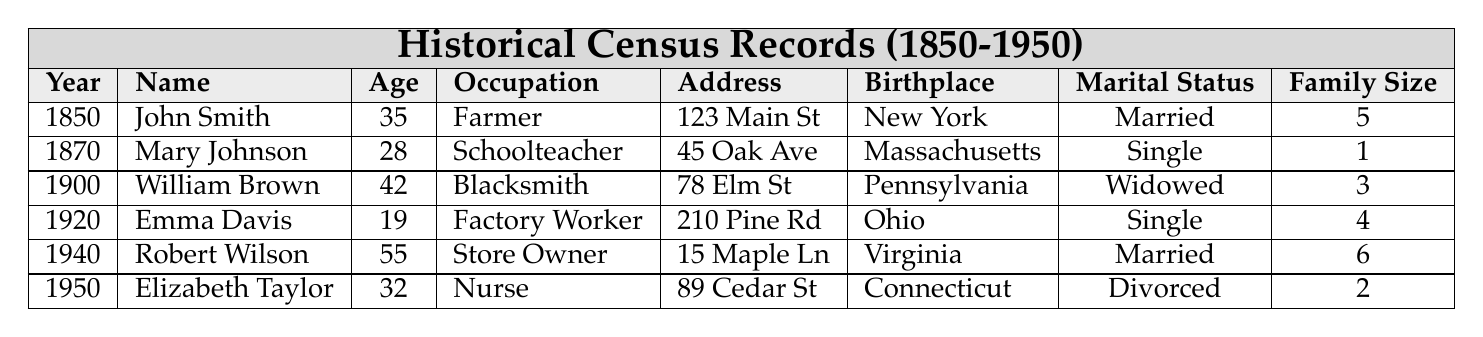What is the occupation of Mary Johnson? The table lists Mary Johnson's occupation as "Schoolteacher" under the 1870 entry.
Answer: Schoolteacher What was the family size of Robert Wilson in 1940? Robert Wilson's family size is indicated in the 1940 entry, which shows a family size of 6.
Answer: 6 How many people were in total in John's family in 1850? The family size listed for John Smith in 1850 is 5, indicating there were a total of 5 people in his household.
Answer: 5 Is Emma Davis married or single? The table shows Emma Davis as "Single" in the 1920 entry under Marital Status.
Answer: Single What is the average age of the individuals listed in the table? The ages are 35, 28, 42, 19, 55, and 32, summing these gives 211. Dividing by 6 entries, the average age is 211/6 = 35.17, which rounds to 35 when considering whole years.
Answer: 35 In which year was Elizabeth Taylor born if she is 32 years old in 1950? If Elizabeth Taylor is 32 years old in 1950, she would have been born in 1950 - 32 = 1918.
Answer: 1918 Who was the blacksmith, and what was his family size? Referring to the table, William Brown was the blacksmith in 1900, and his family size was 3.
Answer: William Brown; 3 Which person listed has the largest family size in the records? Comparing family sizes, Robert Wilson has the largest family size of 6 in 1940.
Answer: Robert Wilson; 6 Did any of the records show a "Divorced" marital status? Yes, Elizabeth Taylor was listed as divorced in the 1950 entry.
Answer: Yes Count how many individuals listed were born in New York or Virginia. John Smith was born in New York, and Robert Wilson was born in Virginia, totaling 2 individuals from these states.
Answer: 2 